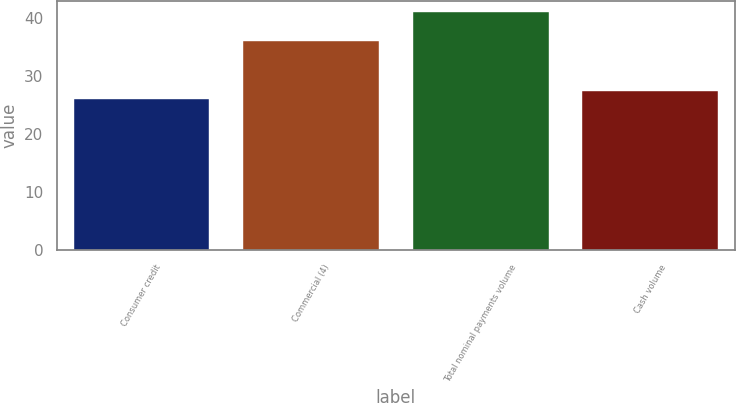<chart> <loc_0><loc_0><loc_500><loc_500><bar_chart><fcel>Consumer credit<fcel>Commercial (4)<fcel>Total nominal payments volume<fcel>Cash volume<nl><fcel>26<fcel>36<fcel>41<fcel>27.5<nl></chart> 